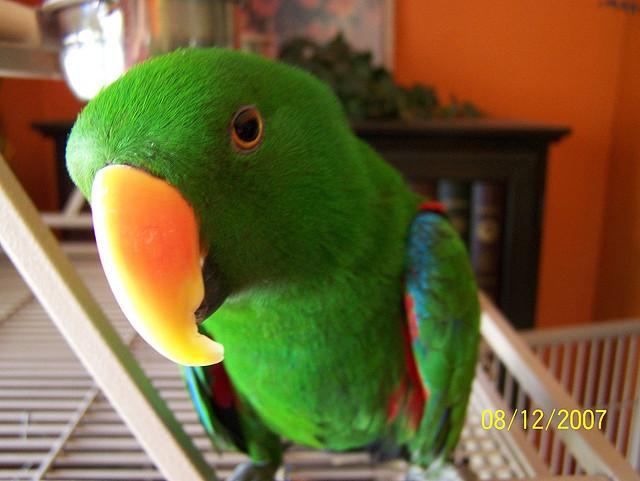What color is the bird's head?
Quick response, please. Green. What main color is the bird?
Answer briefly. Green. What is the bird perched on top of?
Keep it brief. Cage. Is this bird real or fake?
Answer briefly. Real. What year was this photo taken?
Short answer required. 2007. 